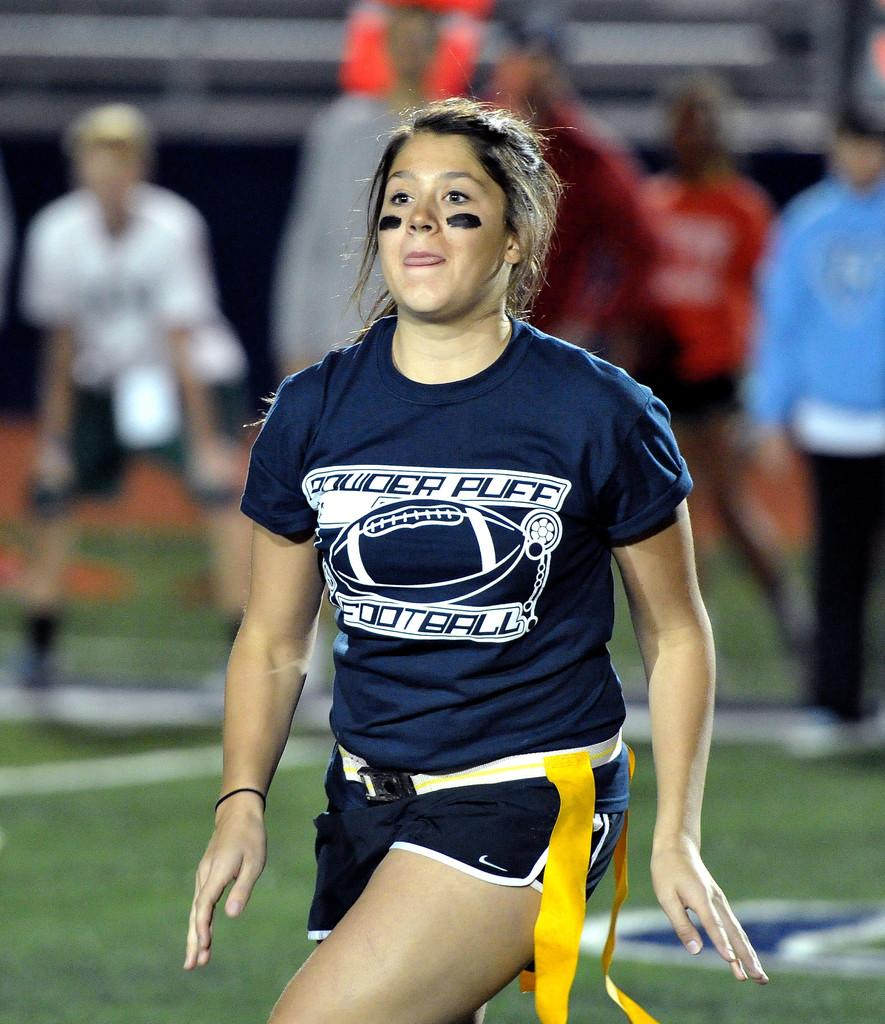<image>
Share a concise interpretation of the image provided. a woman wearing a blue powder puff football shirt 